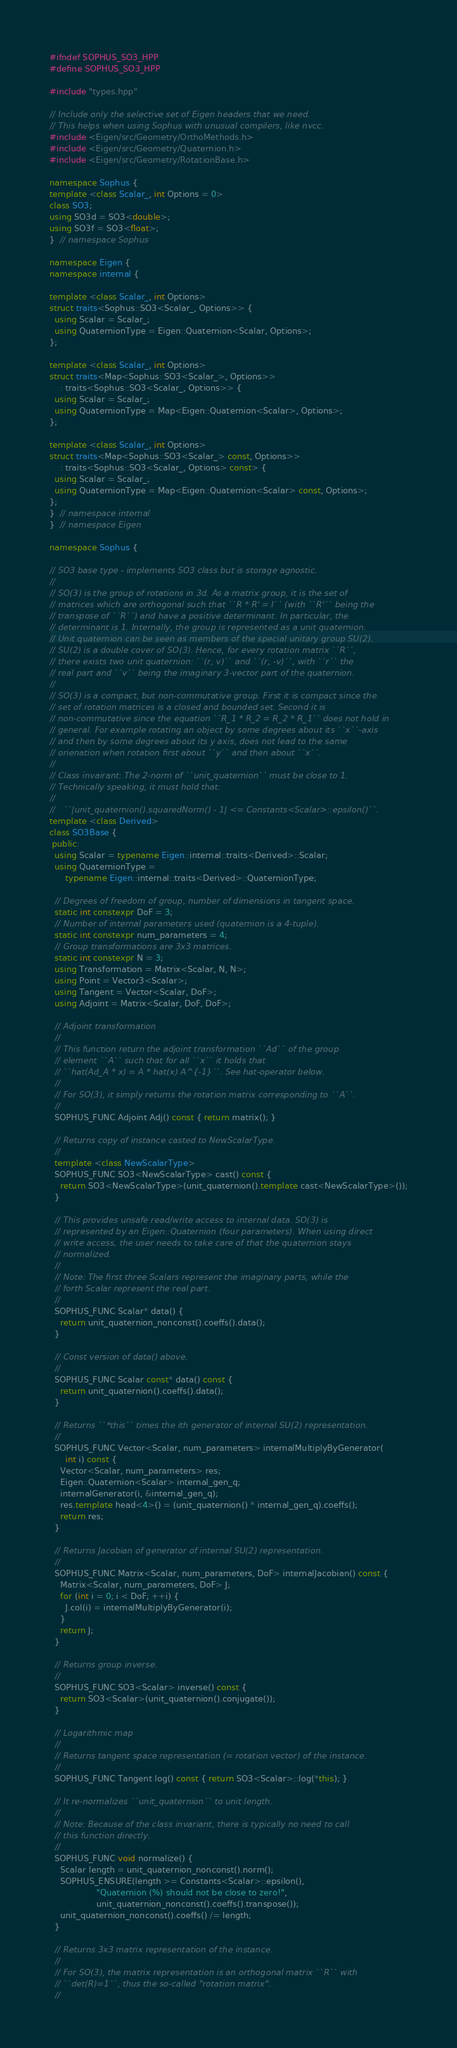<code> <loc_0><loc_0><loc_500><loc_500><_C++_>#ifndef SOPHUS_SO3_HPP
#define SOPHUS_SO3_HPP

#include "types.hpp"

// Include only the selective set of Eigen headers that we need.
// This helps when using Sophus with unusual compilers, like nvcc.
#include <Eigen/src/Geometry/OrthoMethods.h>
#include <Eigen/src/Geometry/Quaternion.h>
#include <Eigen/src/Geometry/RotationBase.h>

namespace Sophus {
template <class Scalar_, int Options = 0>
class SO3;
using SO3d = SO3<double>;
using SO3f = SO3<float>;
}  // namespace Sophus

namespace Eigen {
namespace internal {

template <class Scalar_, int Options>
struct traits<Sophus::SO3<Scalar_, Options>> {
  using Scalar = Scalar_;
  using QuaternionType = Eigen::Quaternion<Scalar, Options>;
};

template <class Scalar_, int Options>
struct traits<Map<Sophus::SO3<Scalar_>, Options>>
    : traits<Sophus::SO3<Scalar_, Options>> {
  using Scalar = Scalar_;
  using QuaternionType = Map<Eigen::Quaternion<Scalar>, Options>;
};

template <class Scalar_, int Options>
struct traits<Map<Sophus::SO3<Scalar_> const, Options>>
    : traits<Sophus::SO3<Scalar_, Options> const> {
  using Scalar = Scalar_;
  using QuaternionType = Map<Eigen::Quaternion<Scalar> const, Options>;
};
}  // namespace internal
}  // namespace Eigen

namespace Sophus {

// SO3 base type - implements SO3 class but is storage agnostic.
//
// SO(3) is the group of rotations in 3d. As a matrix group, it is the set of
// matrices which are orthogonal such that ``R * R' = I`` (with ``R'`` being the
// transpose of ``R``) and have a positive determinant. In particular, the
// determinant is 1. Internally, the group is represented as a unit quaternion.
// Unit quaternion can be seen as members of the special unitary group SU(2).
// SU(2) is a double cover of SO(3). Hence, for every rotation matrix ``R``,
// there exists two unit quaternion: ``(r, v)`` and ``(r, -v)``, with ``r`` the
// real part and ``v`` being the imaginary 3-vector part of the quaternion.
//
// SO(3) is a compact, but non-commutative group. First it is compact since the
// set of rotation matrices is a closed and bounded set. Second it is
// non-commutative since the equation ``R_1 * R_2 = R_2 * R_1`` does not hold in
// general. For example rotating an object by some degrees about its ``x``-axis
// and then by some degrees about its y axis, does not lead to the same
// orienation when rotation first about ``y`` and then about ``x``.
//
// Class invairant: The 2-norm of ``unit_quaternion`` must be close to 1.
// Technically speaking, it must hold that:
//
//   ``|unit_quaternion().squaredNorm() - 1| <= Constants<Scalar>::epsilon()``.
template <class Derived>
class SO3Base {
 public:
  using Scalar = typename Eigen::internal::traits<Derived>::Scalar;
  using QuaternionType =
      typename Eigen::internal::traits<Derived>::QuaternionType;

  // Degrees of freedom of group, number of dimensions in tangent space.
  static int constexpr DoF = 3;
  // Number of internal parameters used (quaternion is a 4-tuple).
  static int constexpr num_parameters = 4;
  // Group transformations are 3x3 matrices.
  static int constexpr N = 3;
  using Transformation = Matrix<Scalar, N, N>;
  using Point = Vector3<Scalar>;
  using Tangent = Vector<Scalar, DoF>;
  using Adjoint = Matrix<Scalar, DoF, DoF>;

  // Adjoint transformation
  //
  // This function return the adjoint transformation ``Ad`` of the group
  // element ``A`` such that for all ``x`` it holds that
  // ``hat(Ad_A * x) = A * hat(x) A^{-1}``. See hat-operator below.
  //
  // For SO(3), it simply returns the rotation matrix corresponding to ``A``.
  //
  SOPHUS_FUNC Adjoint Adj() const { return matrix(); }

  // Returns copy of instance casted to NewScalarType.
  //
  template <class NewScalarType>
  SOPHUS_FUNC SO3<NewScalarType> cast() const {
    return SO3<NewScalarType>(unit_quaternion().template cast<NewScalarType>());
  }

  // This provides unsafe read/write access to internal data. SO(3) is
  // represented by an Eigen::Quaternion (four parameters). When using direct
  // write access, the user needs to take care of that the quaternion stays
  // normalized.
  //
  // Note: The first three Scalars represent the imaginary parts, while the
  // forth Scalar represent the real part.
  //
  SOPHUS_FUNC Scalar* data() {
    return unit_quaternion_nonconst().coeffs().data();
  }

  // Const version of data() above.
  //
  SOPHUS_FUNC Scalar const* data() const {
    return unit_quaternion().coeffs().data();
  }

  // Returns ``*this`` times the ith generator of internal SU(2) representation.
  //
  SOPHUS_FUNC Vector<Scalar, num_parameters> internalMultiplyByGenerator(
      int i) const {
    Vector<Scalar, num_parameters> res;
    Eigen::Quaternion<Scalar> internal_gen_q;
    internalGenerator(i, &internal_gen_q);
    res.template head<4>() = (unit_quaternion() * internal_gen_q).coeffs();
    return res;
  }

  // Returns Jacobian of generator of internal SU(2) representation.
  //
  SOPHUS_FUNC Matrix<Scalar, num_parameters, DoF> internalJacobian() const {
    Matrix<Scalar, num_parameters, DoF> J;
    for (int i = 0; i < DoF; ++i) {
      J.col(i) = internalMultiplyByGenerator(i);
    }
    return J;
  }

  // Returns group inverse.
  //
  SOPHUS_FUNC SO3<Scalar> inverse() const {
    return SO3<Scalar>(unit_quaternion().conjugate());
  }

  // Logarithmic map
  //
  // Returns tangent space representation (= rotation vector) of the instance.
  //
  SOPHUS_FUNC Tangent log() const { return SO3<Scalar>::log(*this); }

  // It re-normalizes ``unit_quaternion`` to unit length.
  //
  // Note: Because of the class invariant, there is typically no need to call
  // this function directly.
  //
  SOPHUS_FUNC void normalize() {
    Scalar length = unit_quaternion_nonconst().norm();
    SOPHUS_ENSURE(length >= Constants<Scalar>::epsilon(),
                  "Quaternion (%) should not be close to zero!",
                  unit_quaternion_nonconst().coeffs().transpose());
    unit_quaternion_nonconst().coeffs() /= length;
  }

  // Returns 3x3 matrix representation of the instance.
  //
  // For SO(3), the matrix representation is an orthogonal matrix ``R`` with
  // ``det(R)=1``, thus the so-called "rotation matrix".
  //</code> 